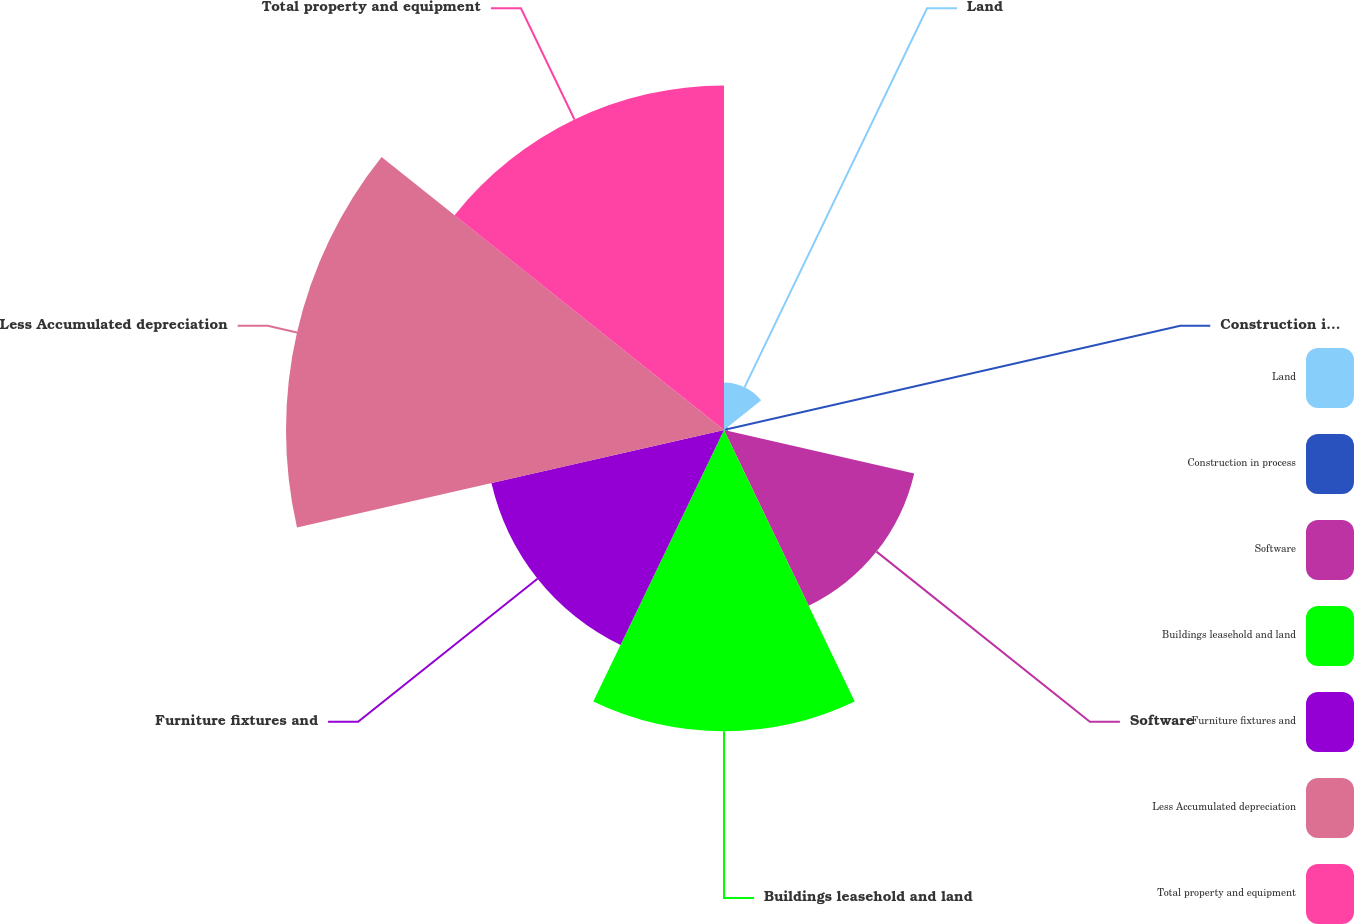Convert chart to OTSL. <chart><loc_0><loc_0><loc_500><loc_500><pie_chart><fcel>Land<fcel>Construction in process<fcel>Software<fcel>Buildings leasehold and land<fcel>Furniture fixtures and<fcel>Less Accumulated depreciation<fcel>Total property and equipment<nl><fcel>3.03%<fcel>0.27%<fcel>12.43%<fcel>19.2%<fcel>15.2%<fcel>27.91%<fcel>21.96%<nl></chart> 